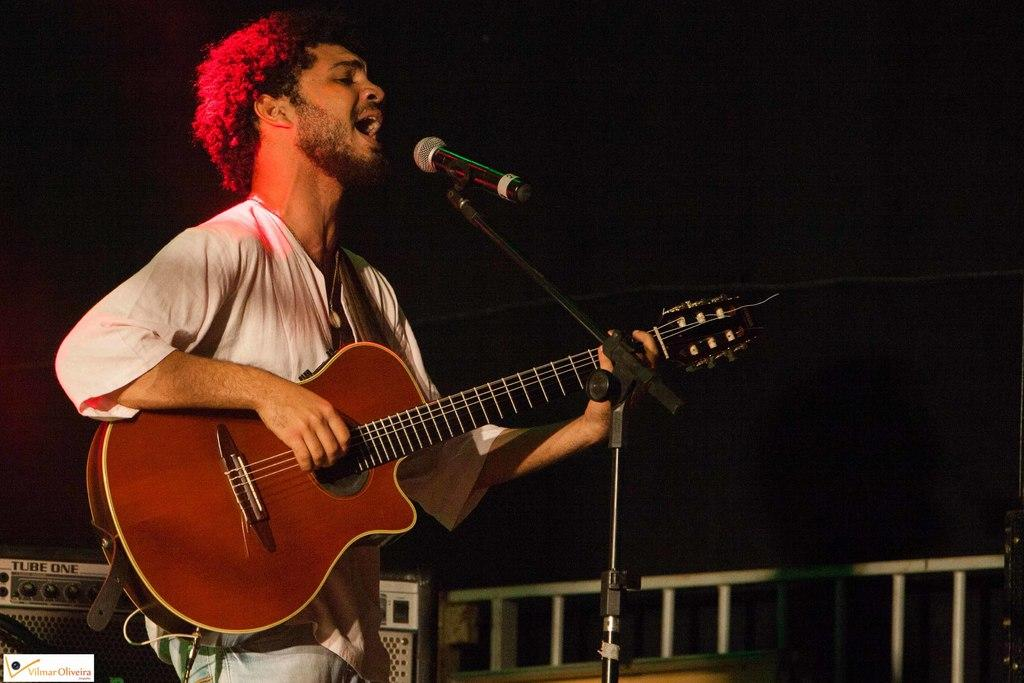What is the man in the image holding? The man is holding a guitar. What is in front of the man? There is a microphone in front of the man. What can be seen in the background of the image? There is a musical set and a railing in the background. What type of zinc is used to polish the guitar in the image? There is no mention of zinc or polishing the guitar in the image. The guitar is simply being held by the man. 